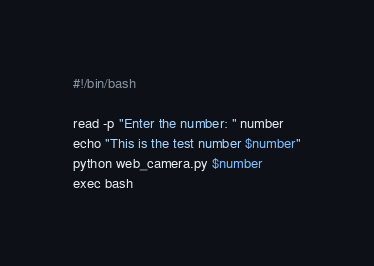<code> <loc_0><loc_0><loc_500><loc_500><_Bash_>#!/bin/bash

read -p "Enter the number: " number
echo "This is the test number $number"
python web_camera.py $number
exec bash</code> 